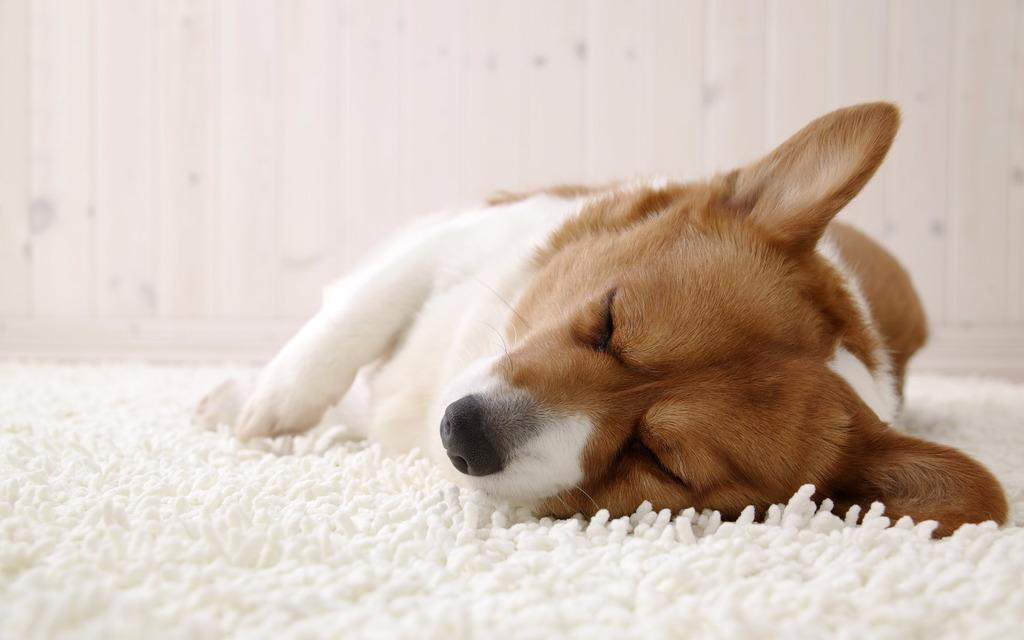What type of animal is in the image? There is a dog in the image. What is the dog doing in the image? The dog is sleeping. What is on the floor in the image? There is a white color floor mat in the image. What can be seen in the background of the image? There is a wall in the background of the image. What type of transport can be seen in the image? There is no transport present in the image. 